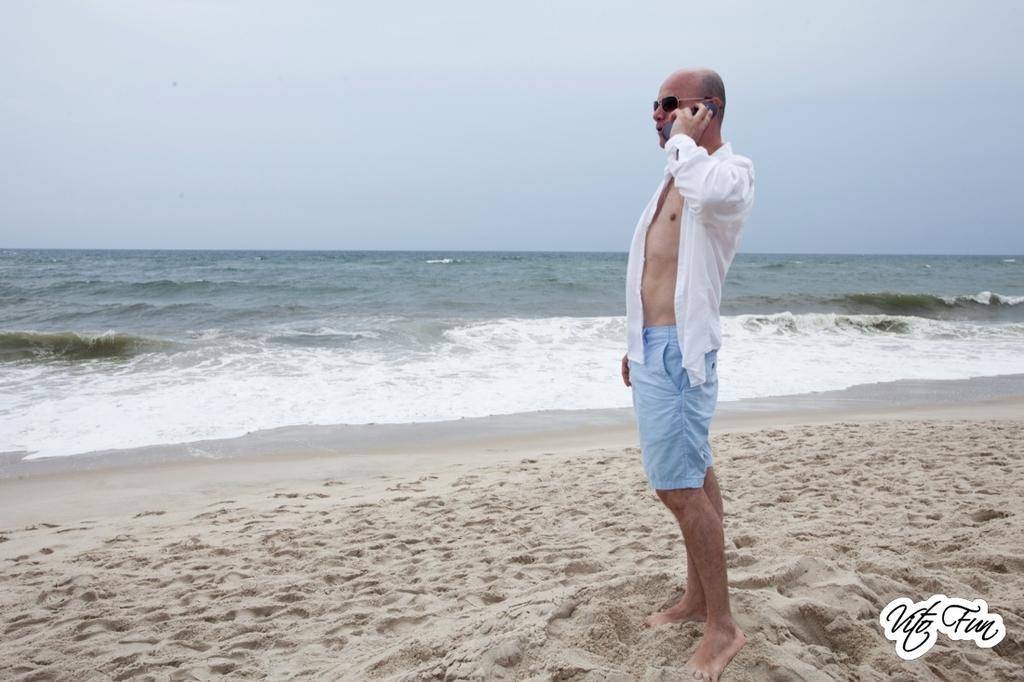Could you give a brief overview of what you see in this image? In this image I can see a person wearing white shirt and blue short is standing on the sand and holding an object in his hand. I can see the sand and the water. In the background I can see the sky. 